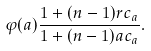Convert formula to latex. <formula><loc_0><loc_0><loc_500><loc_500>\varphi ( a ) \frac { 1 + ( n - 1 ) r c _ { a } } { 1 + ( n - 1 ) a c _ { a } } .</formula> 